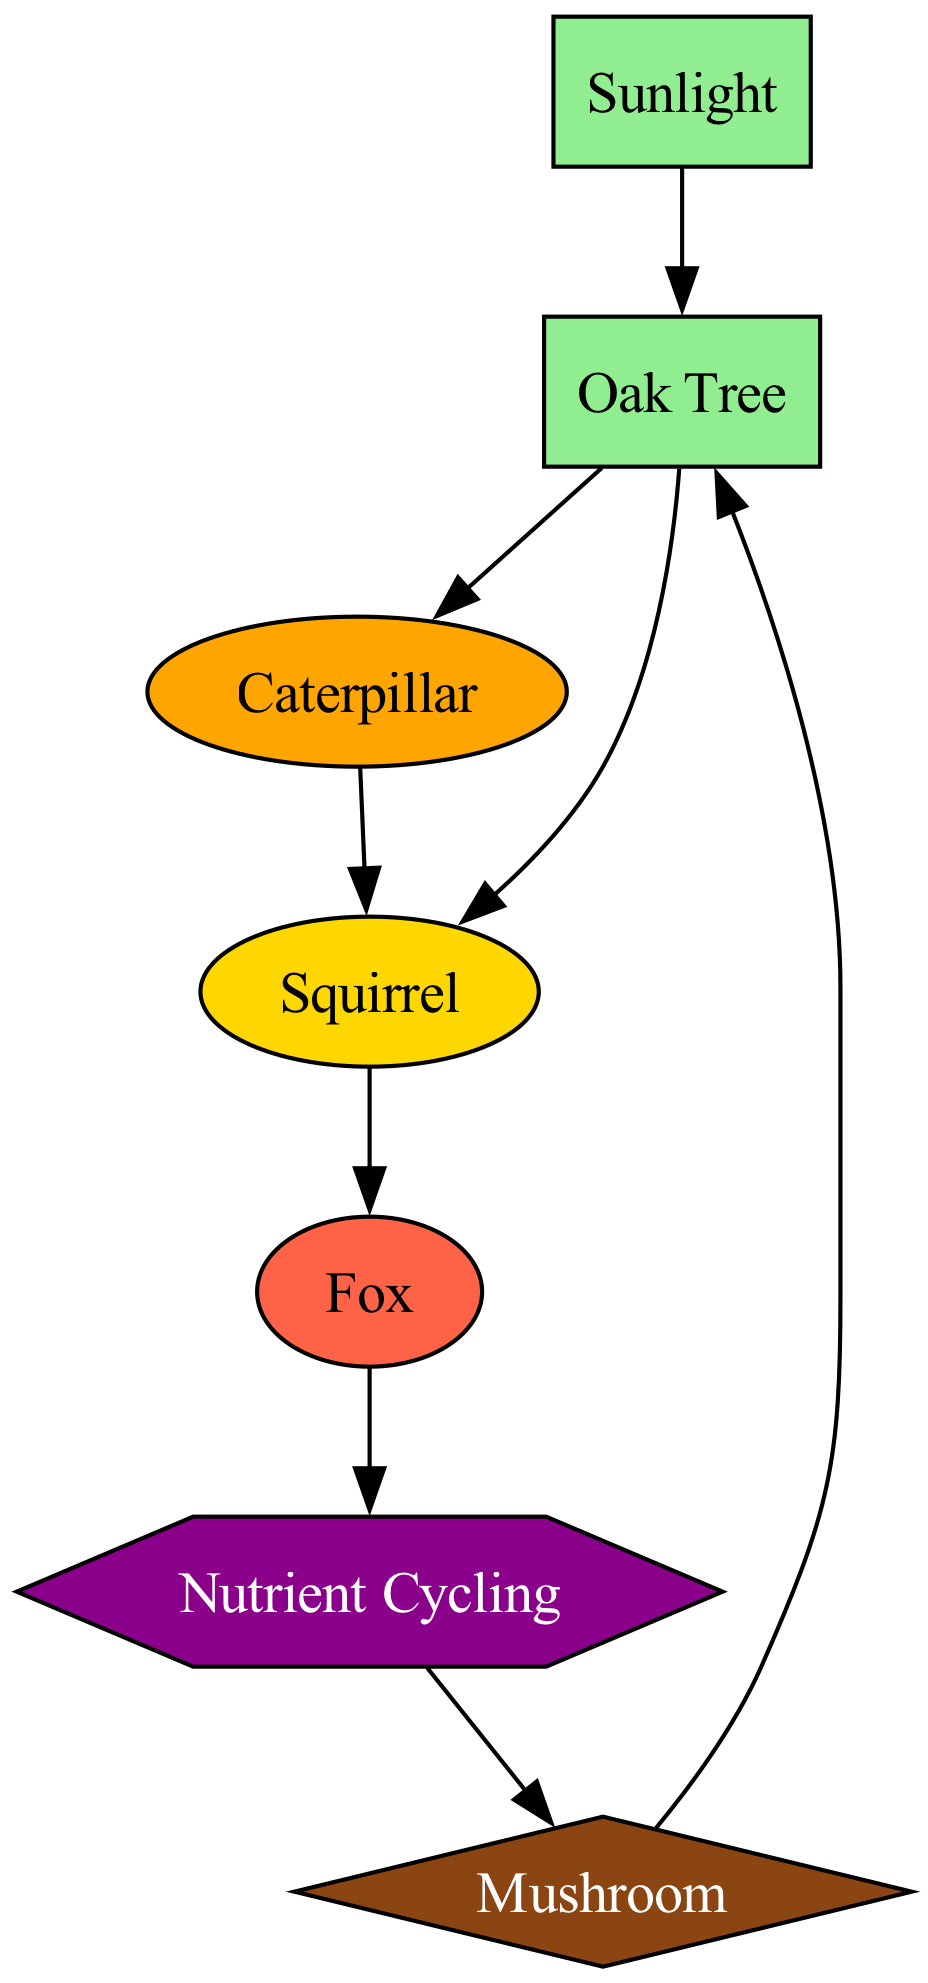What type of element is the Oak Tree? The Oak Tree is categorized as a Producer in the diagram, indicating it generates energy through photosynthesis.
Answer: Producer How many primary consumers are in the diagram? The diagram shows one primary consumer, which is the Caterpillar, that feeds on the Oak Tree.
Answer: 1 Who is the tertiary consumer in the food chain? The Fox is identified as the tertiary consumer; it preys on the Squirrel, the secondary consumer.
Answer: Fox What connects the Fox to the Nutrient Cycling? The Fox is connected to Nutrient Cycling via an arrow, indicating its energy flows into the nutrient cycling process after it is consumed.
Answer: Arrow What is the role of mushrooms in this ecosystem? Mushrooms function as decomposers that break down organic matter, contributing to nutrient cycling within the ecosystem.
Answer: Decomposer How does Nutrient Cycling relate to the Mushroom? Nutrient Cycling leads to Mushroom, illustrating that the nutrients cycled from consumers benefit decomposers like Mushrooms to thrive.
Answer: Nutrient flow How many total edges are present in the diagram? By counting the connections between the nodes, there are eight edges depicted in the food chain.
Answer: 8 Which consumer directly feeds on the Caterpillar? The Squirrel feeds directly on the Caterpillar, as indicated by the edge connecting these two nodes in the flow chart.
Answer: Squirrel What is the energy source for the Oak Tree? The Oak Tree relies on Sunlight as its primary energy source for photosynthesis and growth.
Answer: Sunlight 